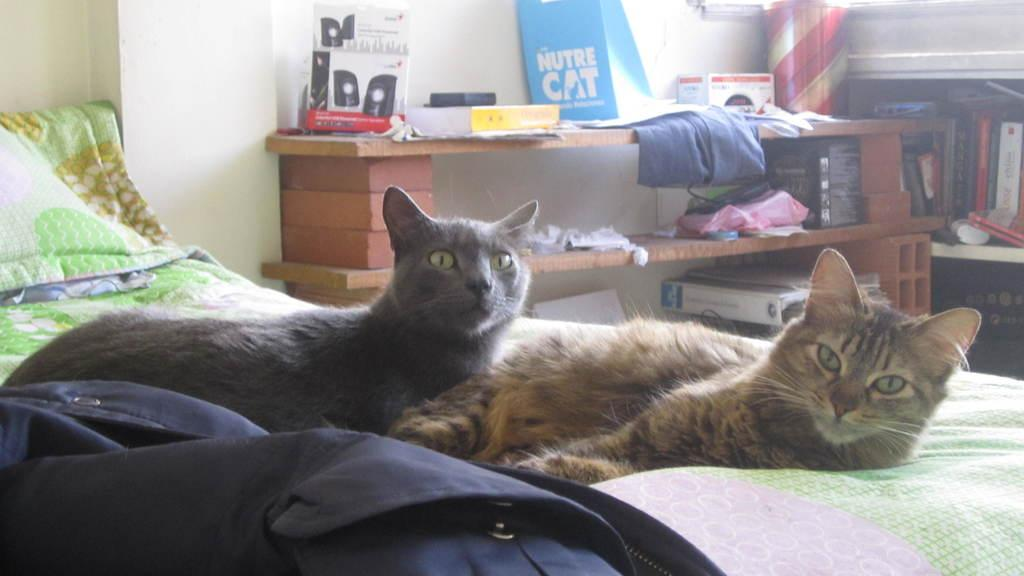What animals can be seen in the foreground of the image? There are two cats on the bed in the foreground of the image. What objects are visible on the table in the background of the image? There are several items placed on a table in the background of the image. What type of storage is used for the books in the background of the image? There is a group of books in a rack in the background of the image. What type of crate can be seen holding the bat in the image? There is no crate or bat present in the image. 